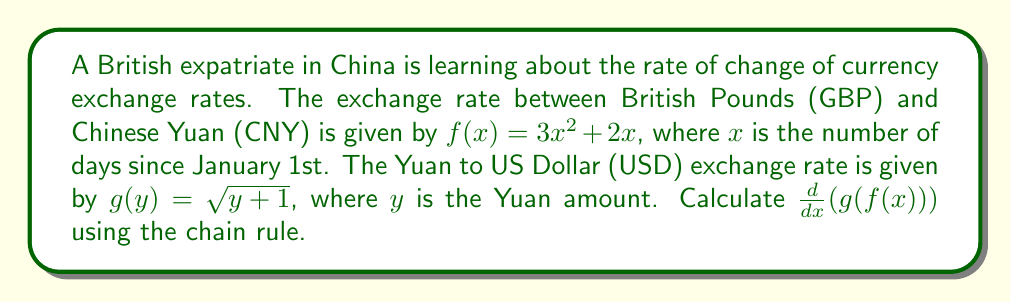Can you answer this question? To solve this problem, we'll use the chain rule for composite functions. The chain rule states that for a composite function $h(x) = g(f(x))$, its derivative is:

$$\frac{d}{dx}(g(f(x))) = g'(f(x)) \cdot f'(x)$$

Let's break this down step-by-step:

1) First, we need to find $f'(x)$:
   $f(x) = 3x^2 + 2x$
   $f'(x) = 6x + 2$

2) Next, we need to find $g'(y)$:
   $g(y) = \sqrt{y + 1}$
   $g'(y) = \frac{1}{2\sqrt{y + 1}}$

3) Now, we substitute $f(x)$ for $y$ in $g'(y)$:
   $g'(f(x)) = \frac{1}{2\sqrt{f(x) + 1}} = \frac{1}{2\sqrt{(3x^2 + 2x) + 1}}$

4) Applying the chain rule:
   $$\frac{d}{dx}(g(f(x))) = g'(f(x)) \cdot f'(x)$$
   $$= \frac{1}{2\sqrt{(3x^2 + 2x) + 1}} \cdot (6x + 2)$$

5) Simplify:
   $$\frac{d}{dx}(g(f(x))) = \frac{6x + 2}{2\sqrt{3x^2 + 2x + 1}}$$
   $$= \frac{3x + 1}{\sqrt{3x^2 + 2x + 1}}$$
Answer: $\frac{d}{dx}(g(f(x))) = \frac{3x + 1}{\sqrt{3x^2 + 2x + 1}}$ 